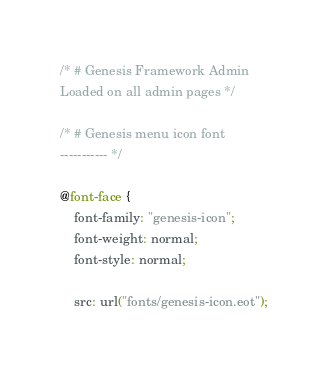<code> <loc_0><loc_0><loc_500><loc_500><_CSS_>/* # Genesis Framework Admin
Loaded on all admin pages */

/* # Genesis menu icon font
----------- */

@font-face {
	font-family: "genesis-icon";
	font-weight: normal;
	font-style: normal;

	src: url("fonts/genesis-icon.eot");</code> 